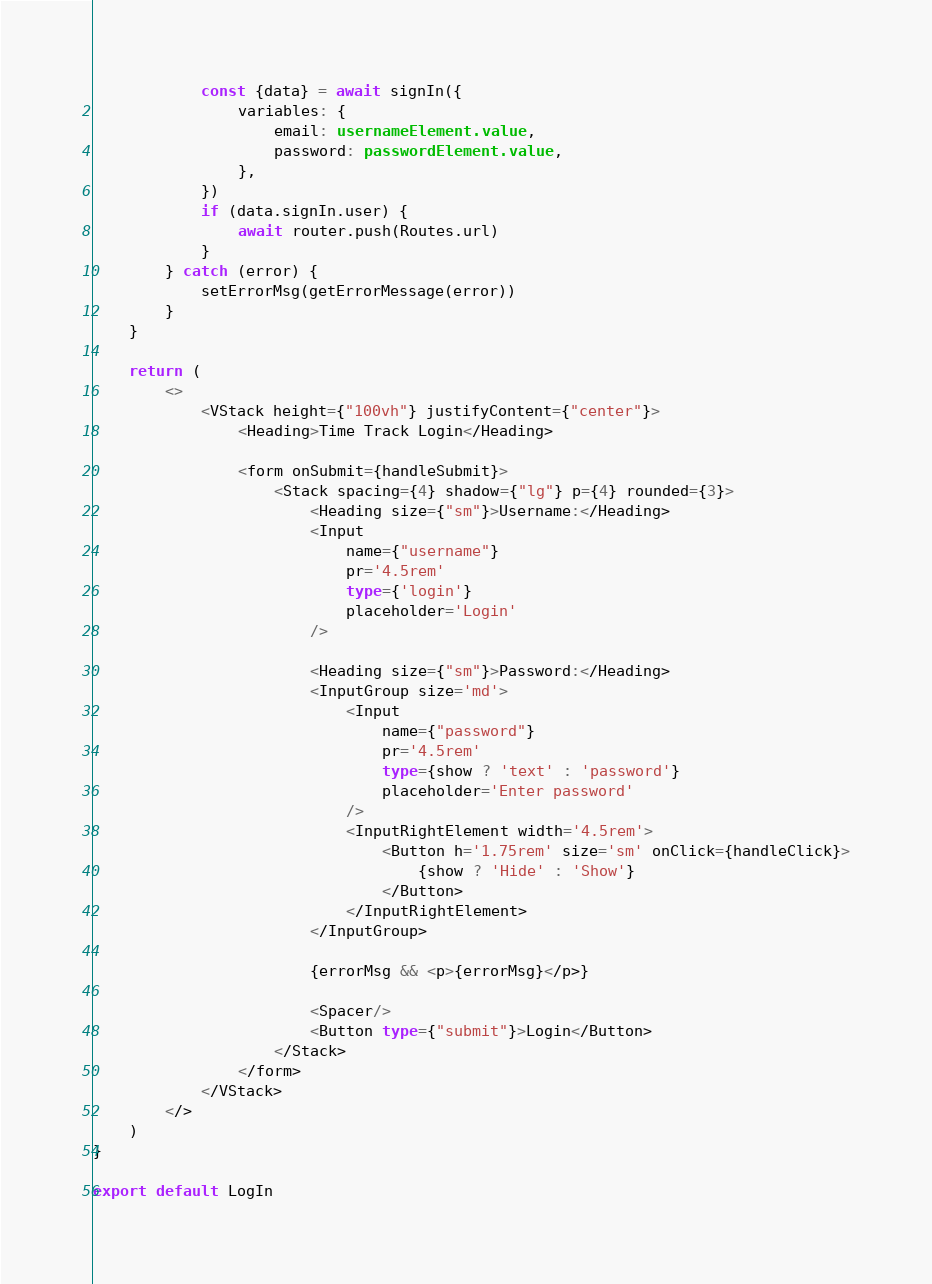Convert code to text. <code><loc_0><loc_0><loc_500><loc_500><_TypeScript_>            const {data} = await signIn({
                variables: {
                    email: usernameElement.value,
                    password: passwordElement.value,
                },
            })
            if (data.signIn.user) {
                await router.push(Routes.url)
            }
        } catch (error) {
            setErrorMsg(getErrorMessage(error))
        }
    }

    return (
        <>
            <VStack height={"100vh"} justifyContent={"center"}>
                <Heading>Time Track Login</Heading>

                <form onSubmit={handleSubmit}>
                    <Stack spacing={4} shadow={"lg"} p={4} rounded={3}>
                        <Heading size={"sm"}>Username:</Heading>
                        <Input
                            name={"username"}
                            pr='4.5rem'
                            type={'login'}
                            placeholder='Login'
                        />

                        <Heading size={"sm"}>Password:</Heading>
                        <InputGroup size='md'>
                            <Input
                                name={"password"}
                                pr='4.5rem'
                                type={show ? 'text' : 'password'}
                                placeholder='Enter password'
                            />
                            <InputRightElement width='4.5rem'>
                                <Button h='1.75rem' size='sm' onClick={handleClick}>
                                    {show ? 'Hide' : 'Show'}
                                </Button>
                            </InputRightElement>
                        </InputGroup>

                        {errorMsg && <p>{errorMsg}</p>}

                        <Spacer/>
                        <Button type={"submit"}>Login</Button>
                    </Stack>
                </form>
            </VStack>
        </>
    )
}

export default LogIn
</code> 